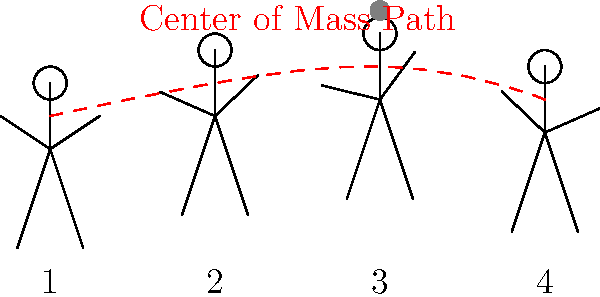In a typical Diego Costa header, at which point during the movement sequence does the center of mass reach its highest position, and how does this relate to the effectiveness of the header? To understand the center of mass shifts during a header, let's analyze the movement sequence:

1. Initial stance: The player's center of mass is relatively low as they prepare for the jump.

2. Take-off: As the player begins to jump, their center of mass starts to rise.

3. Mid-air contact: This is the crucial moment when the player makes contact with the ball. The center of mass reaches its highest point here, allowing for maximum power and control.

4. Landing: After contact, the player's center of mass begins to descend as they return to the ground.

The effectiveness of the header is directly related to the position of the center of mass at the point of contact:

a) Maximum height: By reaching the highest point at ball contact, the player can meet the ball above defenders, increasing the chances of winning the header.

b) Power generation: At the apex of the jump, the player can use their entire body to generate force, transferring it through the center of mass to the ball.

c) Directional control: With the body at its highest point, the player has better body control and can more accurately direct the ball.

d) Timing: The highest point coincides with the optimal moment to strike the ball, allowing for precise timing.

For a player like Diego Costa, known for his physical presence and aerial ability, maximizing this center of mass position is crucial for dominating in the air and scoring headers.
Answer: Point 3 (mid-air contact); maximizes height, power, and control 